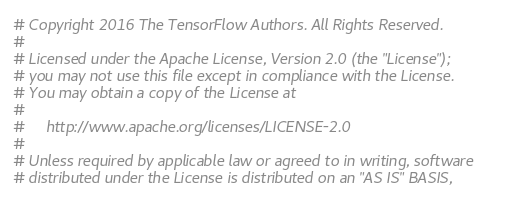Convert code to text. <code><loc_0><loc_0><loc_500><loc_500><_Python_># Copyright 2016 The TensorFlow Authors. All Rights Reserved.
#
# Licensed under the Apache License, Version 2.0 (the "License");
# you may not use this file except in compliance with the License.
# You may obtain a copy of the License at
#
#     http://www.apache.org/licenses/LICENSE-2.0
#
# Unless required by applicable law or agreed to in writing, software
# distributed under the License is distributed on an "AS IS" BASIS,</code> 